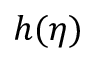<formula> <loc_0><loc_0><loc_500><loc_500>h ( \eta )</formula> 